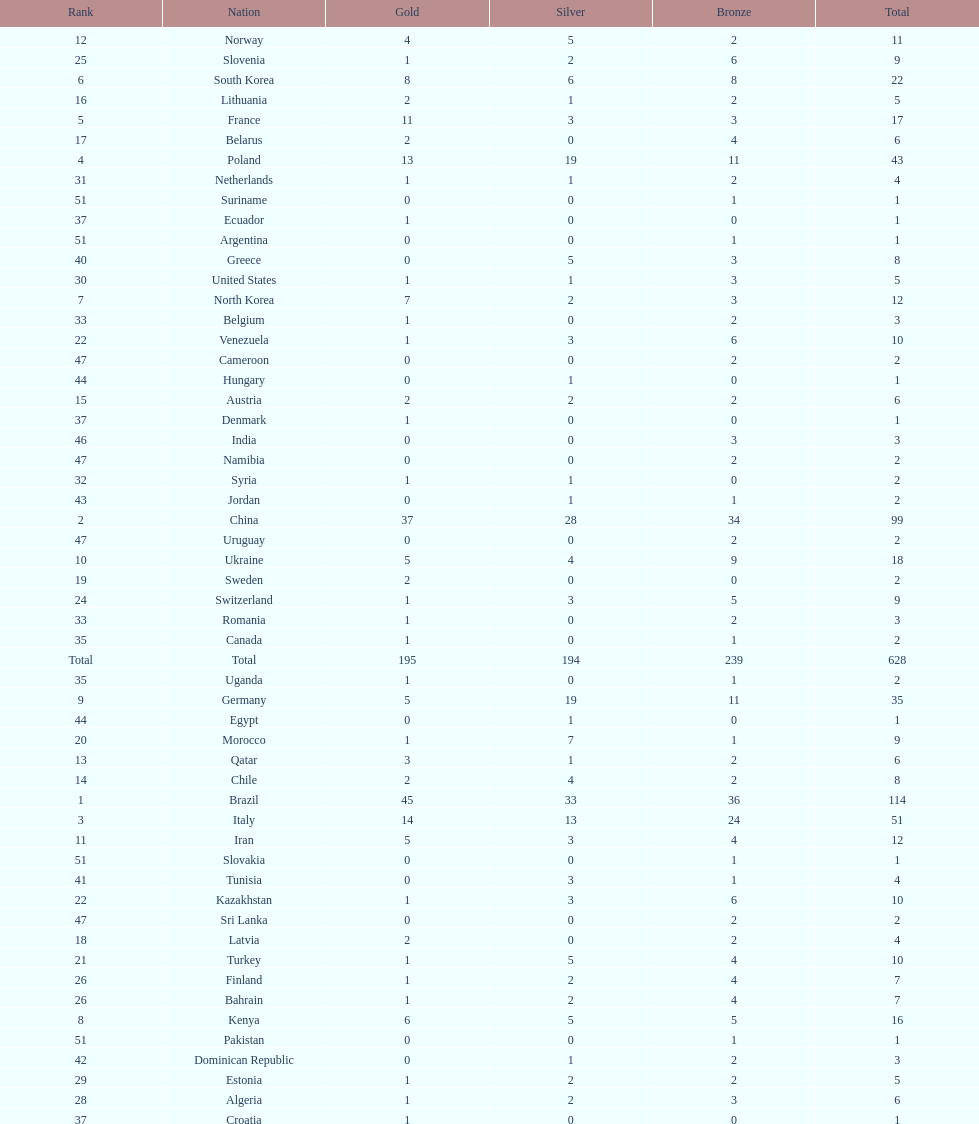What is the total number of medals between south korea, north korea, sweden, and brazil? 150. 